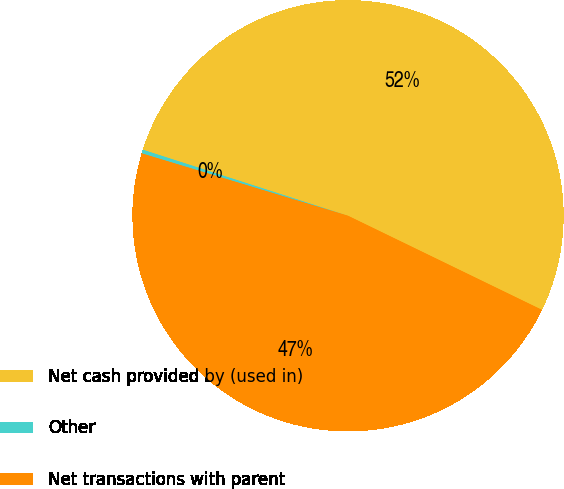Convert chart. <chart><loc_0><loc_0><loc_500><loc_500><pie_chart><fcel>Net cash provided by (used in)<fcel>Other<fcel>Net transactions with parent<nl><fcel>52.23%<fcel>0.28%<fcel>47.48%<nl></chart> 